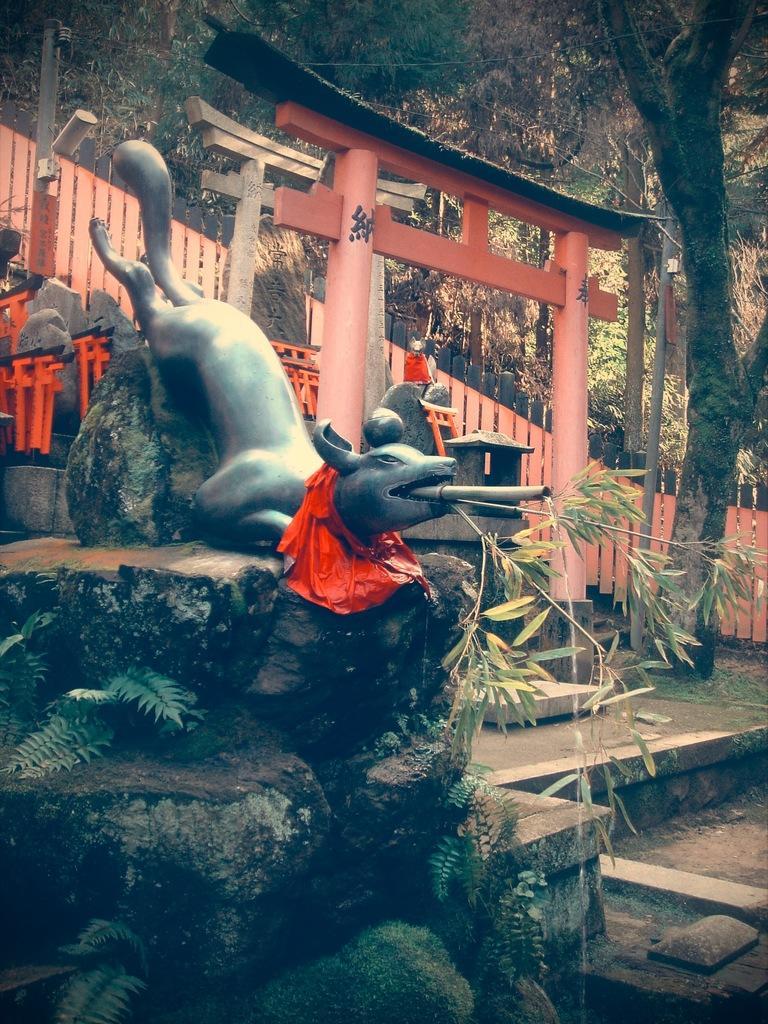Describe this image in one or two sentences. In this image there is a depiction of an animal on the rocks structure and there are leaves of a plant, behind that there is an arch, wooden fencing and in the background there are trees. 